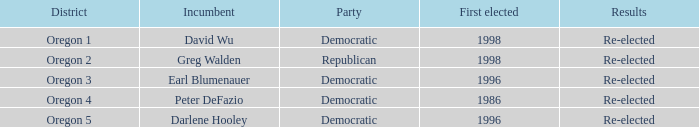Which Democratic incumbent was first elected in 1998? David Wu. 